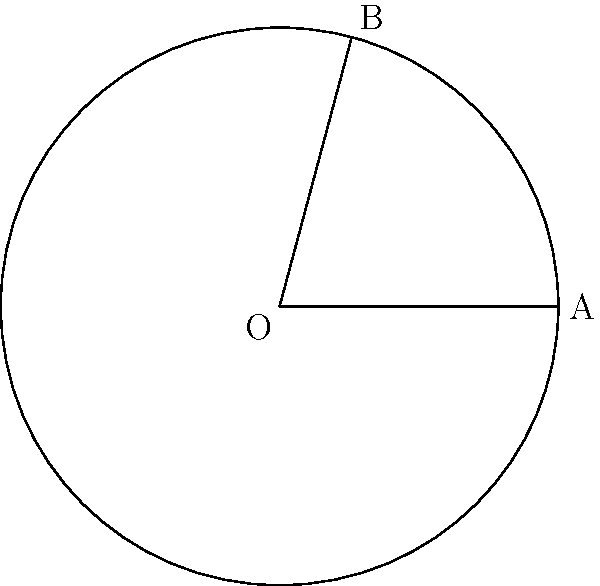In your latest lighthouse-themed clock face painting, you've created a sector representing 5 hours. If the entire clock face spans 360°, what is the central angle of this 5-hour sector in degrees? Let's approach this step-by-step:

1) First, we need to understand the relationship between hours and degrees in a clock:
   - A full clock (12 hours) corresponds to 360°
   
2) We can set up a proportion:
   12 hours : 360° = 5 hours : x°

3) Cross multiply:
   12x = 360 * 5

4) Solve for x:
   x = (360 * 5) / 12
   
5) Simplify:
   x = 1800 / 12
   x = 150

Therefore, the central angle of the 5-hour sector is 150°.
Answer: 150° 